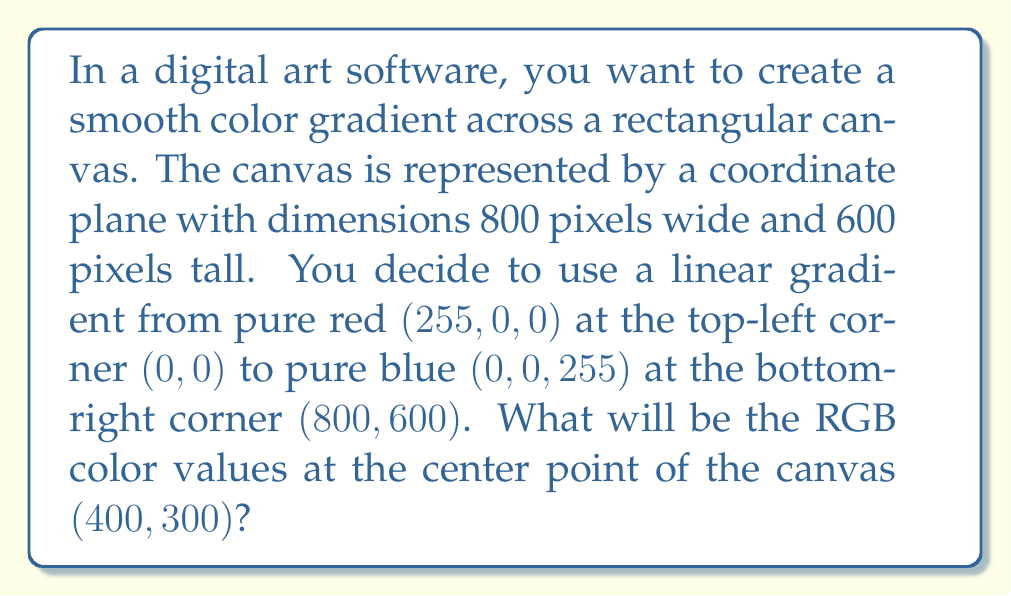Could you help me with this problem? To solve this problem, we need to follow these steps:

1) First, let's understand how the color changes across the canvas:
   - Red component decreases from 255 to 0
   - Blue component increases from 0 to 255
   - Green component remains 0 throughout

2) We can use linear interpolation to calculate the color values at any point. The general formula for linear interpolation is:

   $$f(x) = f(x_1) + \frac{x - x_1}{x_2 - x_1} \cdot (f(x_2) - f(x_1))$$

3) For our problem, we need to interpolate in 2D. We can do this by calculating the percentage distance from the top-left corner to the bottom-right corner.

4) The center point $(400, 300)$ is exactly halfway between the corners in both dimensions.

5) For the red component:
   $$R = 255 - (0.5 \cdot (255 - 0)) = 255 - 127.5 = 127.5$$

6) For the blue component:
   $$B = 0 + (0.5 \cdot (255 - 0)) = 0 + 127.5 = 127.5$$

7) The green component remains 0.

8) Since RGB values are typically integers, we round these values to the nearest whole number.
Answer: The RGB color values at the center point $(400, 300)$ will be $(128, 0, 128)$. 